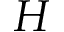<formula> <loc_0><loc_0><loc_500><loc_500>H</formula> 